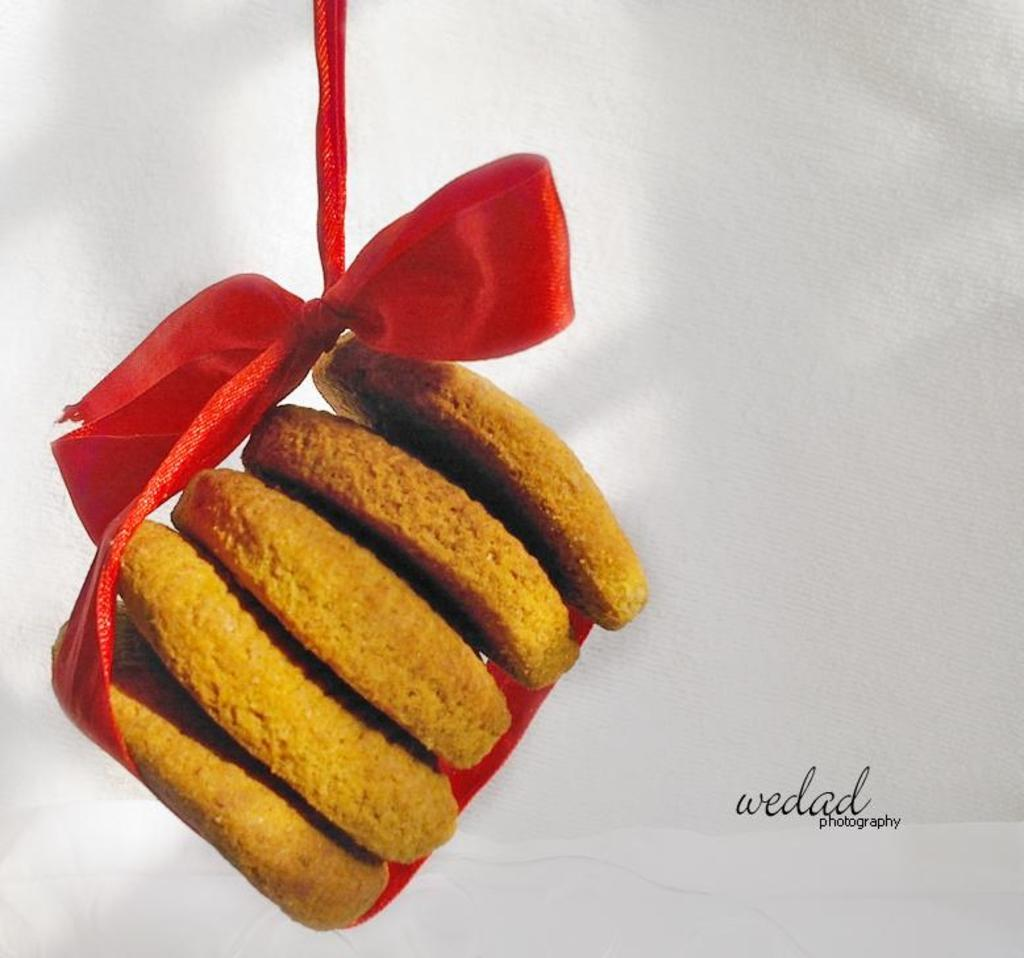What type of food can be seen in the image? There are cookies in the image. How are the cookies arranged or decorated? The cookies are tied with a red ribbon. What color is the background of the image? The background of the image is white. Is there any additional information or branding on the image? Yes, there is a watermark on the right side of the image. Are there any poisonous substances present in the cookies in the image? There is no indication of poisonous substances in the image; it only shows cookies tied with a red ribbon. Can you see any cobwebs in the image? There are no cobwebs visible in the image, as it only features cookies and a white background. 